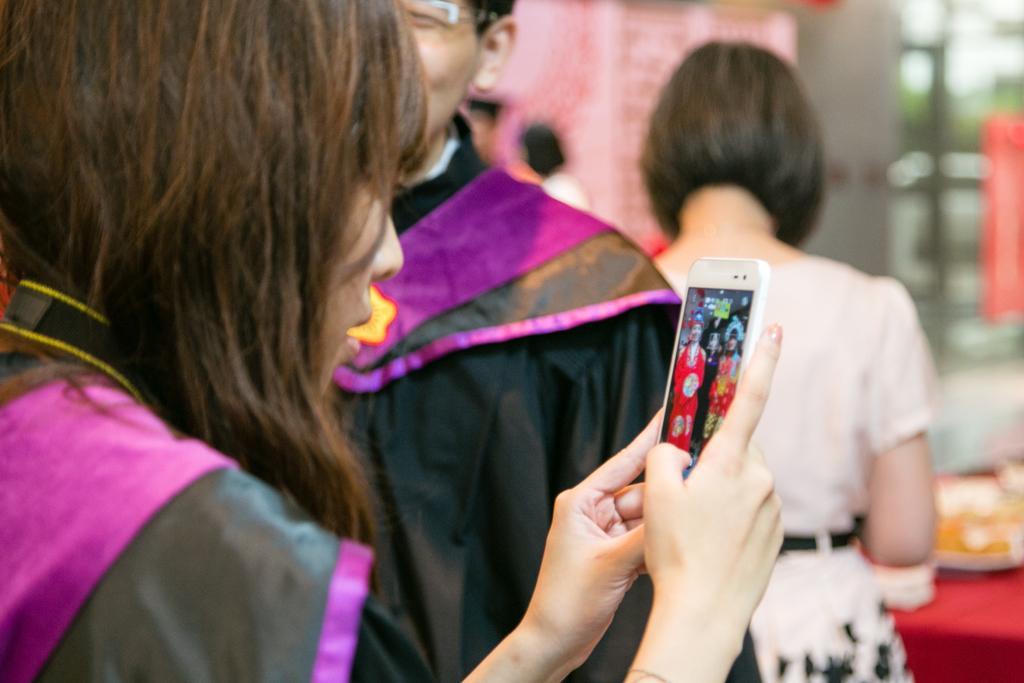Can you describe this image briefly? In this image there is a girl who is using the mobile. In the background there is a man who is wearing the black coat and a girl beside him. 